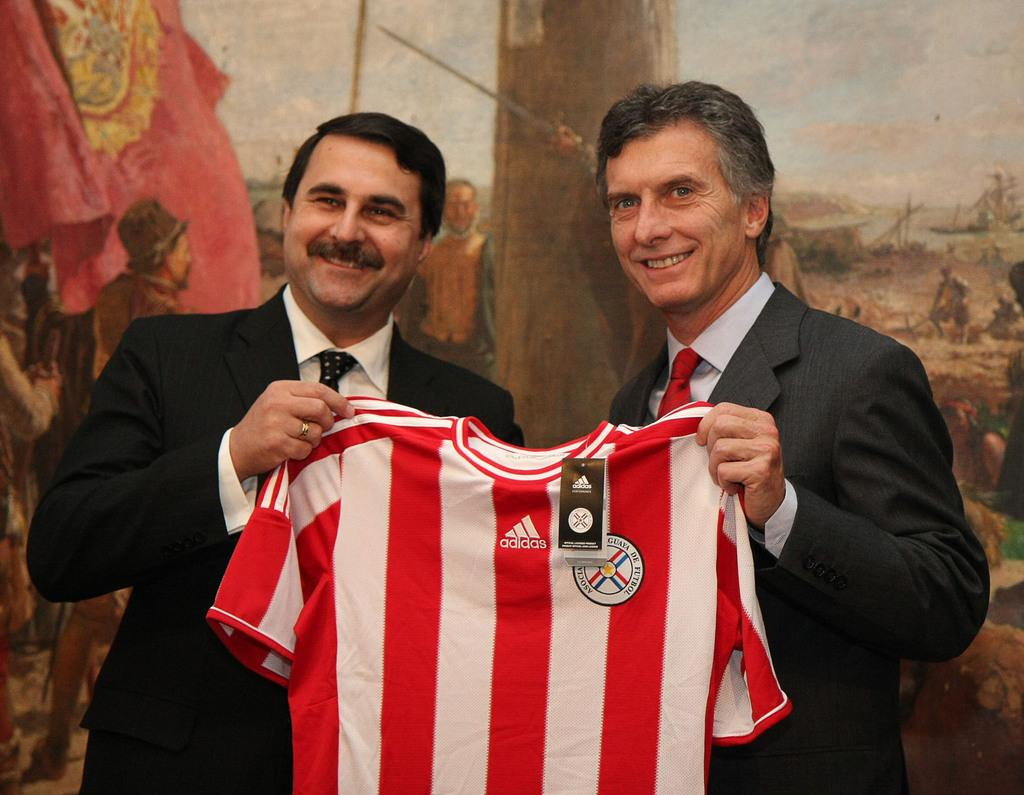<image>
Render a clear and concise summary of the photo. Two men holding up a new Adidas sport jersey 